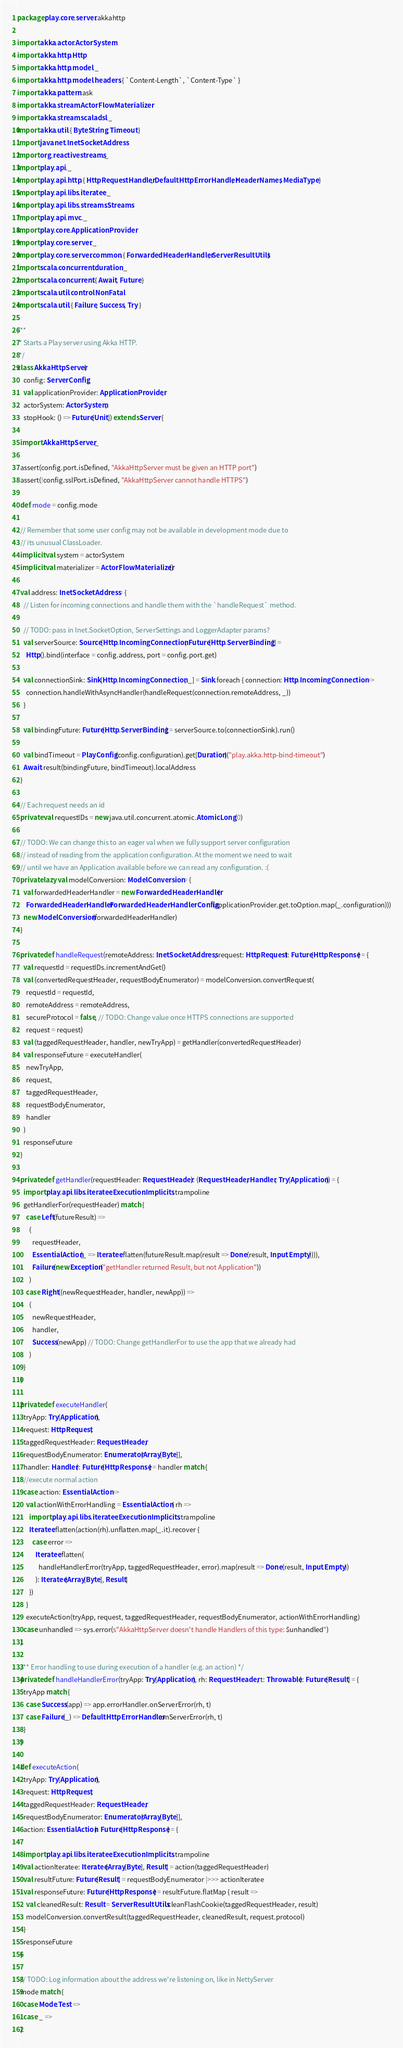Convert code to text. <code><loc_0><loc_0><loc_500><loc_500><_Scala_>package play.core.server.akkahttp

import akka.actor.ActorSystem
import akka.http.Http
import akka.http.model._
import akka.http.model.headers.{ `Content-Length`, `Content-Type` }
import akka.pattern.ask
import akka.stream.ActorFlowMaterializer
import akka.stream.scaladsl._
import akka.util.{ ByteString, Timeout }
import java.net.InetSocketAddress
import org.reactivestreams._
import play.api._
import play.api.http.{ HttpRequestHandler, DefaultHttpErrorHandler, HeaderNames, MediaType }
import play.api.libs.iteratee._
import play.api.libs.streams.Streams
import play.api.mvc._
import play.core.ApplicationProvider
import play.core.server._
import play.core.server.common.{ ForwardedHeaderHandler, ServerResultUtils }
import scala.concurrent.duration._
import scala.concurrent.{ Await, Future }
import scala.util.control.NonFatal
import scala.util.{ Failure, Success, Try }

/**
 * Starts a Play server using Akka HTTP.
 */
class AkkaHttpServer(
    config: ServerConfig,
    val applicationProvider: ApplicationProvider,
    actorSystem: ActorSystem,
    stopHook: () => Future[Unit]) extends Server {

  import AkkaHttpServer._

  assert(config.port.isDefined, "AkkaHttpServer must be given an HTTP port")
  assert(!config.sslPort.isDefined, "AkkaHttpServer cannot handle HTTPS")

  def mode = config.mode

  // Remember that some user config may not be available in development mode due to
  // its unusual ClassLoader.
  implicit val system = actorSystem
  implicit val materializer = ActorFlowMaterializer()

  val address: InetSocketAddress = {
    // Listen for incoming connections and handle them with the `handleRequest` method.

    // TODO: pass in Inet.SocketOption, ServerSettings and LoggerAdapter params?
    val serverSource: Source[Http.IncomingConnection, Future[Http.ServerBinding]] =
      Http().bind(interface = config.address, port = config.port.get)

    val connectionSink: Sink[Http.IncomingConnection, _] = Sink.foreach { connection: Http.IncomingConnection =>
      connection.handleWithAsyncHandler(handleRequest(connection.remoteAddress, _))
    }

    val bindingFuture: Future[Http.ServerBinding] = serverSource.to(connectionSink).run()

    val bindTimeout = PlayConfig(config.configuration).get[Duration]("play.akka.http-bind-timeout")
    Await.result(bindingFuture, bindTimeout).localAddress
  }

  // Each request needs an id
  private val requestIDs = new java.util.concurrent.atomic.AtomicLong(0)

  // TODO: We can change this to an eager val when we fully support server configuration
  // instead of reading from the application configuration. At the moment we need to wait
  // until we have an Application available before we can read any configuration. :(
  private lazy val modelConversion: ModelConversion = {
    val forwardedHeaderHandler = new ForwardedHeaderHandler(
      ForwardedHeaderHandler.ForwardedHeaderHandlerConfig(applicationProvider.get.toOption.map(_.configuration)))
    new ModelConversion(forwardedHeaderHandler)
  }

  private def handleRequest(remoteAddress: InetSocketAddress, request: HttpRequest): Future[HttpResponse] = {
    val requestId = requestIDs.incrementAndGet()
    val (convertedRequestHeader, requestBodyEnumerator) = modelConversion.convertRequest(
      requestId = requestId,
      remoteAddress = remoteAddress,
      secureProtocol = false, // TODO: Change value once HTTPS connections are supported
      request = request)
    val (taggedRequestHeader, handler, newTryApp) = getHandler(convertedRequestHeader)
    val responseFuture = executeHandler(
      newTryApp,
      request,
      taggedRequestHeader,
      requestBodyEnumerator,
      handler
    )
    responseFuture
  }

  private def getHandler(requestHeader: RequestHeader): (RequestHeader, Handler, Try[Application]) = {
    import play.api.libs.iteratee.Execution.Implicits.trampoline
    getHandlerFor(requestHeader) match {
      case Left(futureResult) =>
        (
          requestHeader,
          EssentialAction(_ => Iteratee.flatten(futureResult.map(result => Done(result, Input.Empty)))),
          Failure(new Exception("getHandler returned Result, but not Application"))
        )
      case Right((newRequestHeader, handler, newApp)) =>
        (
          newRequestHeader,
          handler,
          Success(newApp) // TODO: Change getHandlerFor to use the app that we already had
        )
    }
  }

  private def executeHandler(
    tryApp: Try[Application],
    request: HttpRequest,
    taggedRequestHeader: RequestHeader,
    requestBodyEnumerator: Enumerator[Array[Byte]],
    handler: Handler): Future[HttpResponse] = handler match {
    //execute normal action
    case action: EssentialAction =>
      val actionWithErrorHandling = EssentialAction { rh =>
        import play.api.libs.iteratee.Execution.Implicits.trampoline
        Iteratee.flatten(action(rh).unflatten.map(_.it).recover {
          case error =>
            Iteratee.flatten(
              handleHandlerError(tryApp, taggedRequestHeader, error).map(result => Done(result, Input.Empty))
            ): Iteratee[Array[Byte], Result]
        })
      }
      executeAction(tryApp, request, taggedRequestHeader, requestBodyEnumerator, actionWithErrorHandling)
    case unhandled => sys.error(s"AkkaHttpServer doesn't handle Handlers of this type: $unhandled")
  }

  /** Error handling to use during execution of a handler (e.g. an action) */
  private def handleHandlerError(tryApp: Try[Application], rh: RequestHeader, t: Throwable): Future[Result] = {
    tryApp match {
      case Success(app) => app.errorHandler.onServerError(rh, t)
      case Failure(_) => DefaultHttpErrorHandler.onServerError(rh, t)
    }
  }

  def executeAction(
    tryApp: Try[Application],
    request: HttpRequest,
    taggedRequestHeader: RequestHeader,
    requestBodyEnumerator: Enumerator[Array[Byte]],
    action: EssentialAction): Future[HttpResponse] = {

    import play.api.libs.iteratee.Execution.Implicits.trampoline
    val actionIteratee: Iteratee[Array[Byte], Result] = action(taggedRequestHeader)
    val resultFuture: Future[Result] = requestBodyEnumerator |>>> actionIteratee
    val responseFuture: Future[HttpResponse] = resultFuture.flatMap { result =>
      val cleanedResult: Result = ServerResultUtils.cleanFlashCookie(taggedRequestHeader, result)
      modelConversion.convertResult(taggedRequestHeader, cleanedResult, request.protocol)
    }
    responseFuture
  }

  // TODO: Log information about the address we're listening on, like in NettyServer
  mode match {
    case Mode.Test =>
    case _ =>
  }
</code> 